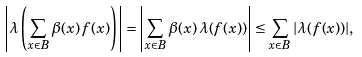<formula> <loc_0><loc_0><loc_500><loc_500>\left | \lambda \left ( \sum _ { x \in B } \beta ( x ) \, f ( x ) \right ) \right | = \left | \sum _ { x \in B } \beta ( x ) \, \lambda ( f ( x ) ) \right | \leq \sum _ { x \in B } | \lambda ( f ( x ) ) | ,</formula> 